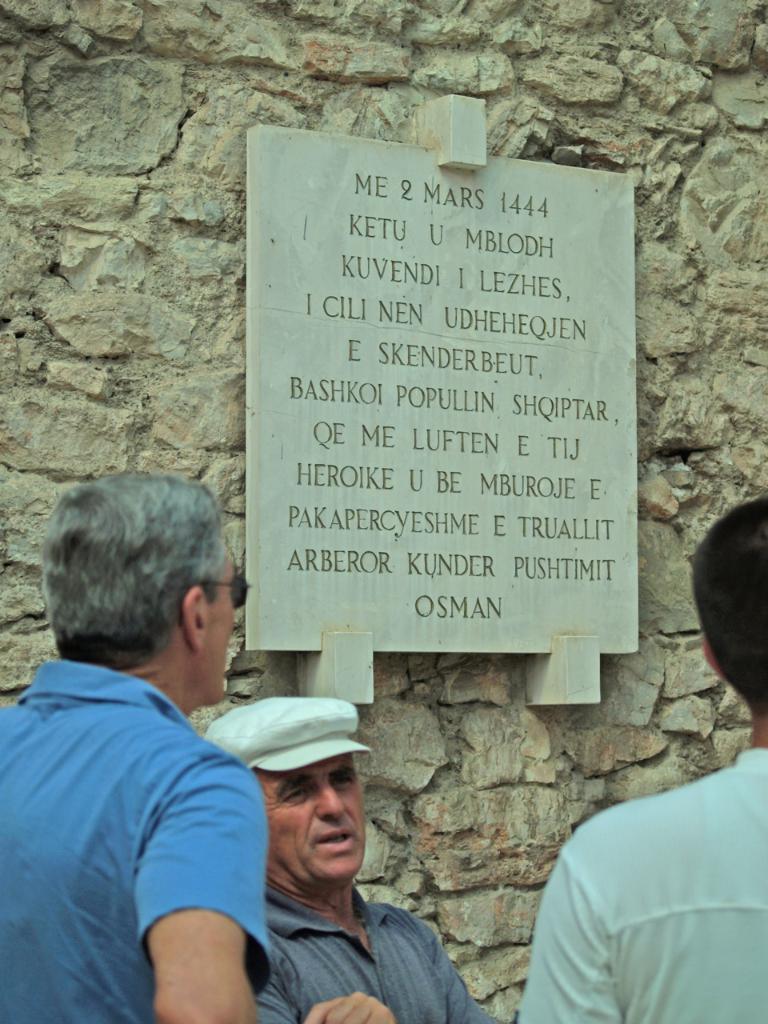In one or two sentences, can you explain what this image depicts? In this image in the front there are persons. In the background there is a wall and on the wall there is a board hanging with some text written on it. 